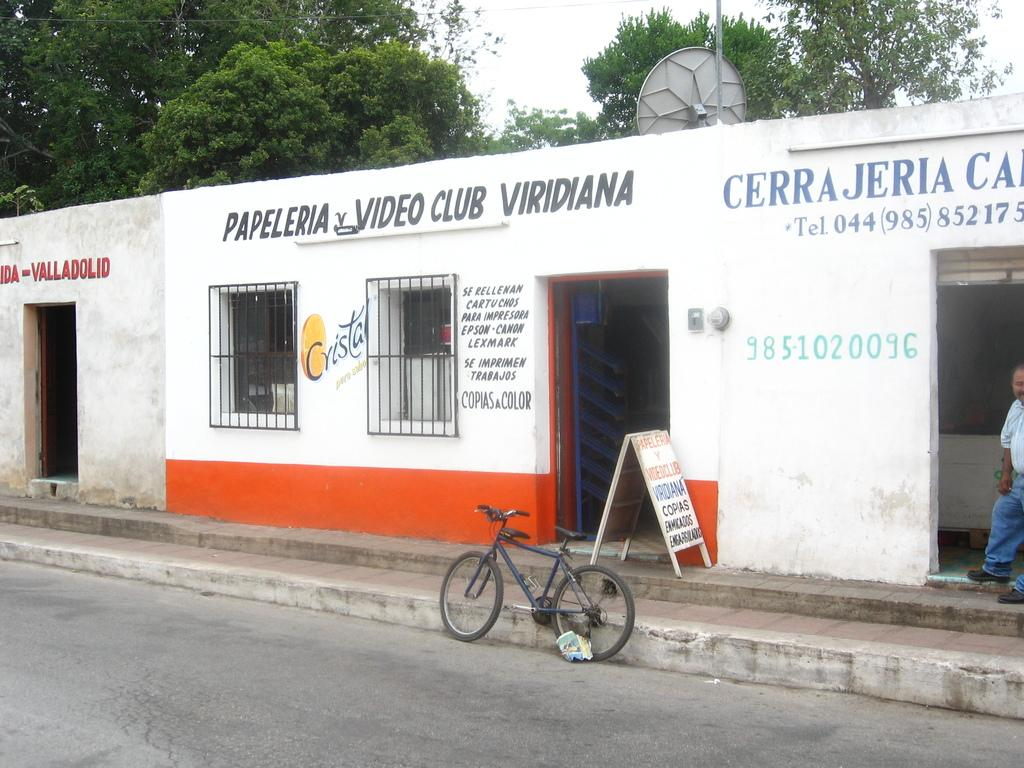What architectural features are located in the center of the image? There are doors and windows in the center of the image. What type of structure do these doors and windows belong to? These doors and windows belong to a building. What mode of transportation can be seen at the bottom of the image? There is a cycle visible at the bottom of the image. Where is the cycle located in relation to the building? The cycle is on a road. What can be seen in the background of the image? There are trees and the sky visible in the background of the image. How does the cycle start to move in the image? The image does not show the cycle starting to move; it is already on the road. What type of trouble is the building experiencing in the image? There is no indication of any trouble or problem with the building in the image. 